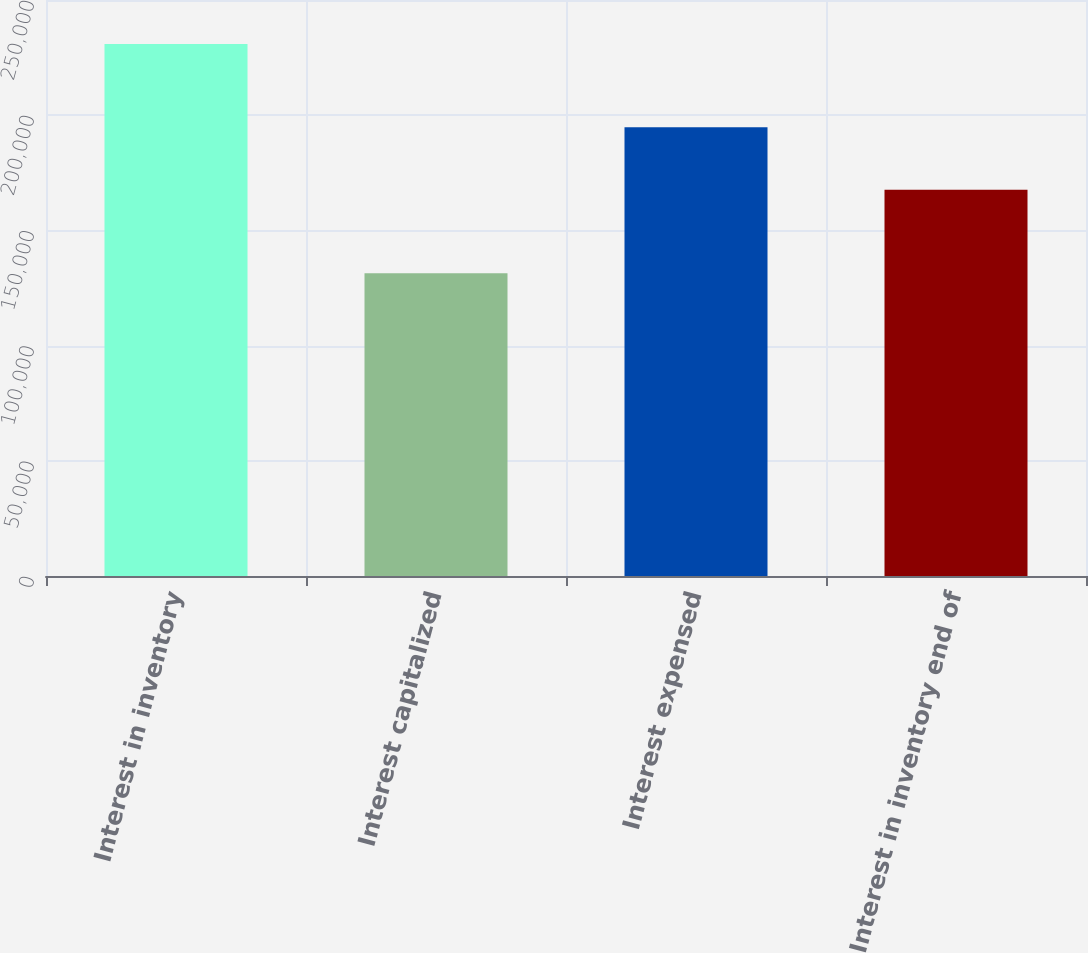Convert chart. <chart><loc_0><loc_0><loc_500><loc_500><bar_chart><fcel>Interest in inventory<fcel>Interest capitalized<fcel>Interest expensed<fcel>Interest in inventory end of<nl><fcel>230922<fcel>131444<fcel>194728<fcel>167638<nl></chart> 